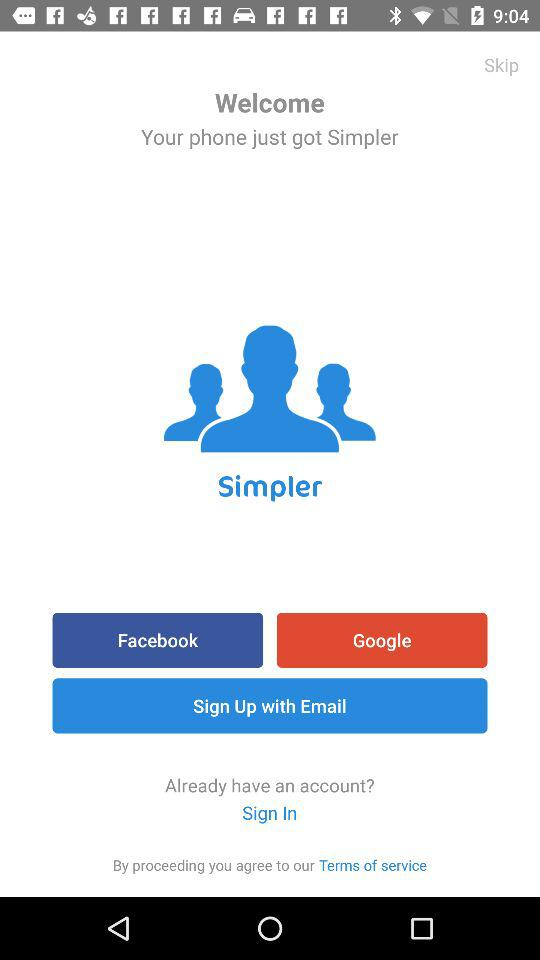What are the options for sign up? The options are "Facebook", "Google" and "Email". 